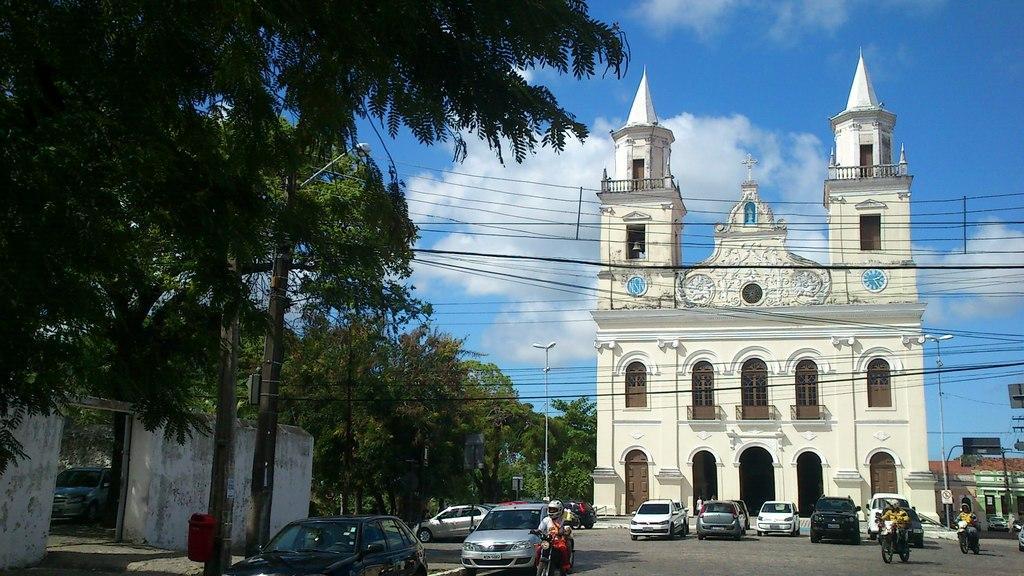In one or two sentences, can you explain what this image depicts? In this image, there are a few buildings, trees, poles, wires, boards, vehicles. We can see some people. Among them, some people are riding motor vehicles. We can see the ground. We can also see the sky with clouds. 